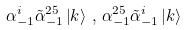Convert formula to latex. <formula><loc_0><loc_0><loc_500><loc_500>\alpha ^ { i } _ { - 1 } \tilde { \alpha } ^ { 2 5 } _ { - 1 } \left | k \right > \, , \, \alpha ^ { 2 5 } _ { - 1 } \tilde { \alpha } ^ { i } _ { - 1 } \left | k \right ></formula> 